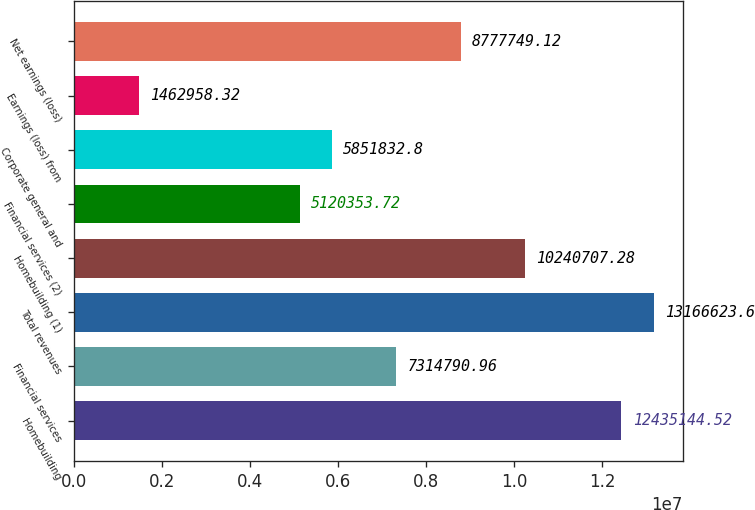<chart> <loc_0><loc_0><loc_500><loc_500><bar_chart><fcel>Homebuilding<fcel>Financial services<fcel>Total revenues<fcel>Homebuilding (1)<fcel>Financial services (2)<fcel>Corporate general and<fcel>Earnings (loss) from<fcel>Net earnings (loss)<nl><fcel>1.24351e+07<fcel>7.31479e+06<fcel>1.31666e+07<fcel>1.02407e+07<fcel>5.12035e+06<fcel>5.85183e+06<fcel>1.46296e+06<fcel>8.77775e+06<nl></chart> 